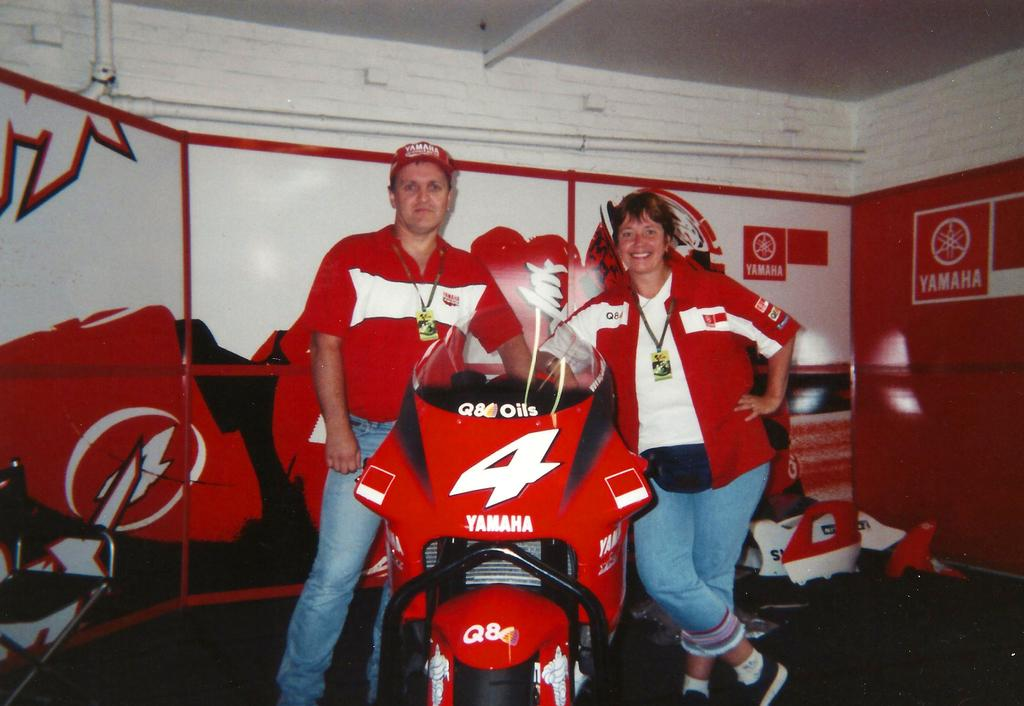<image>
Share a concise interpretation of the image provided. A man and woman are posing by a Yamaha racing bike. 